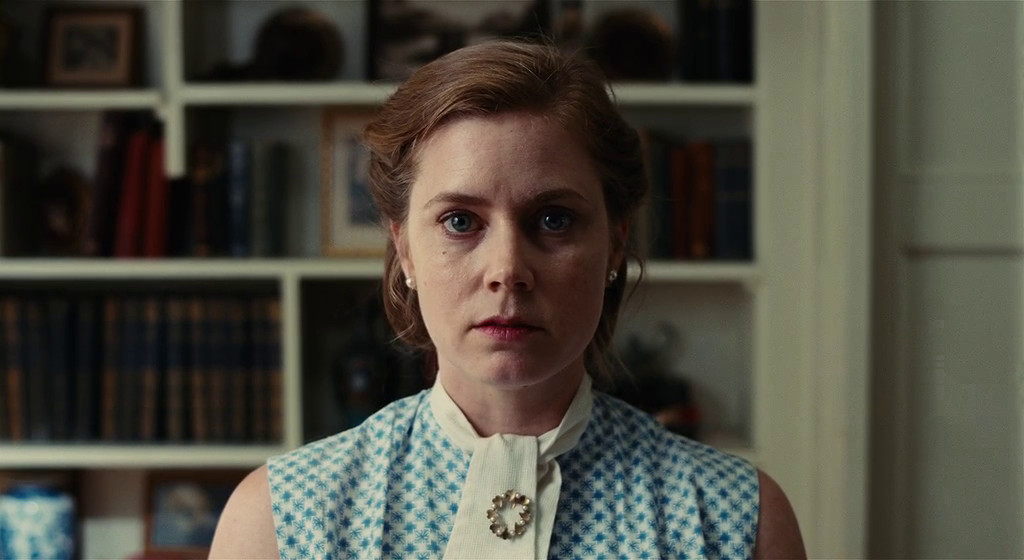Could you describe the mood of this character based on her expression and setting? The character's expression is contemplative and intense, which, when combined with the scholarly background filled with books, suggests she is possibly grappling with a complex issue or decision. Her serious demeanor and the quiet environment indicate a moment of solitude and reflection. 